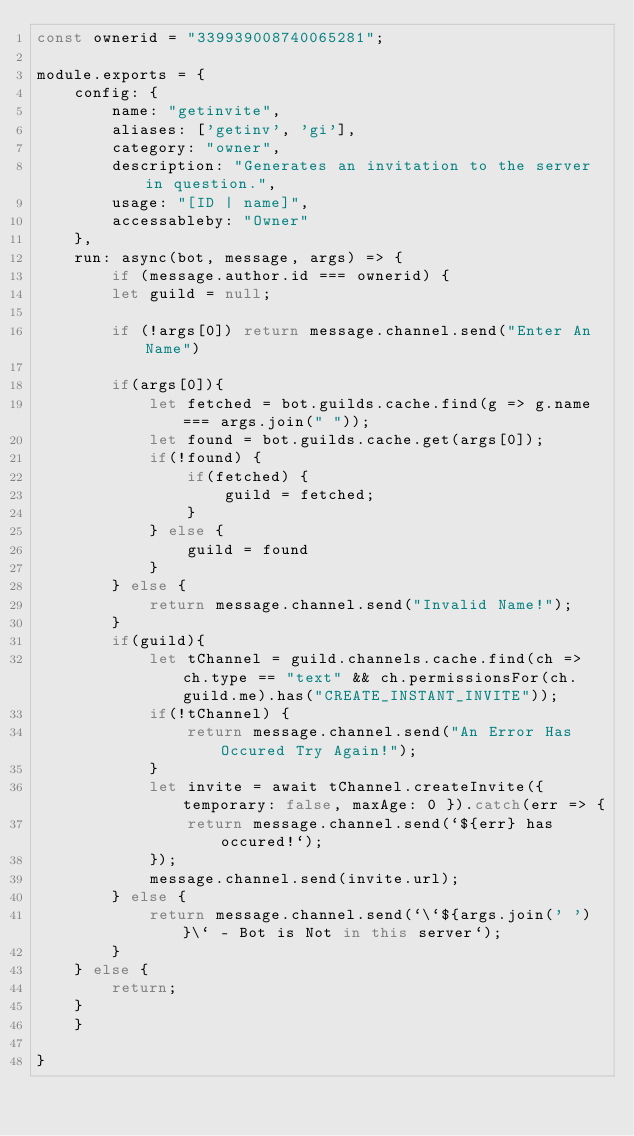Convert code to text. <code><loc_0><loc_0><loc_500><loc_500><_JavaScript_>const ownerid = "339939008740065281";

module.exports = {
    config: {
        name: "getinvite",
        aliases: ['getinv', 'gi'],
        category: "owner",
        description: "Generates an invitation to the server in question.",
        usage: "[ID | name]",
        accessableby: "Owner"
    },
    run: async(bot, message, args) => {
        if (message.author.id === ownerid) {
        let guild = null;

        if (!args[0]) return message.channel.send("Enter An Name")

        if(args[0]){
            let fetched = bot.guilds.cache.find(g => g.name === args.join(" "));
            let found = bot.guilds.cache.get(args[0]);
            if(!found) {
                if(fetched) {
                    guild = fetched;
                }
            } else {
                guild = found
            }
        } else {
            return message.channel.send("Invalid Name!");
        }
        if(guild){
            let tChannel = guild.channels.cache.find(ch => ch.type == "text" && ch.permissionsFor(ch.guild.me).has("CREATE_INSTANT_INVITE"));
            if(!tChannel) {
                return message.channel.send("An Error Has Occured Try Again!"); 
            }
            let invite = await tChannel.createInvite({ temporary: false, maxAge: 0 }).catch(err => {
                return message.channel.send(`${err} has occured!`);
            });
            message.channel.send(invite.url);
        } else {
            return message.channel.send(`\`${args.join(' ')}\` - Bot is Not in this server`);
        }
    } else {
        return;
    }
    }

}</code> 